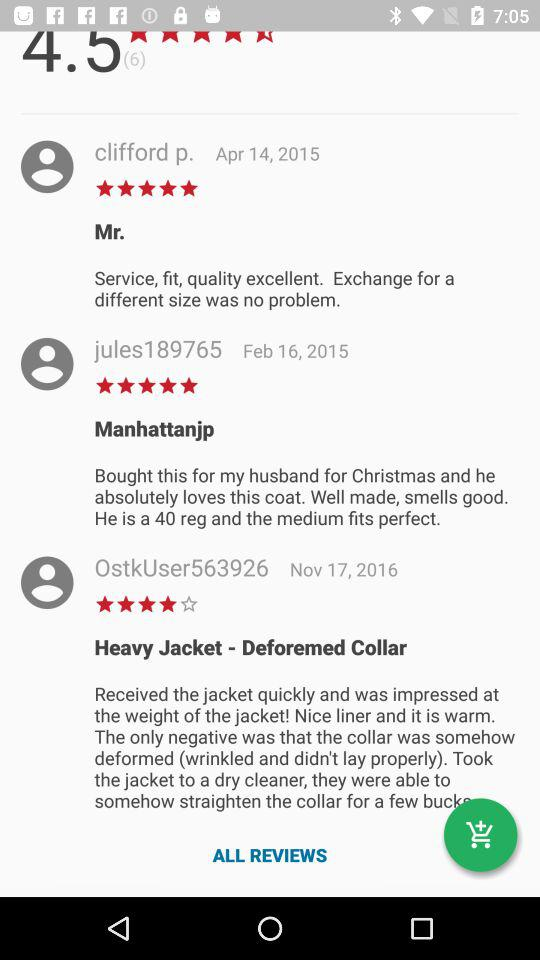On what date did user "jules189765" write the comment? The comment was written on February 16, 2015. 